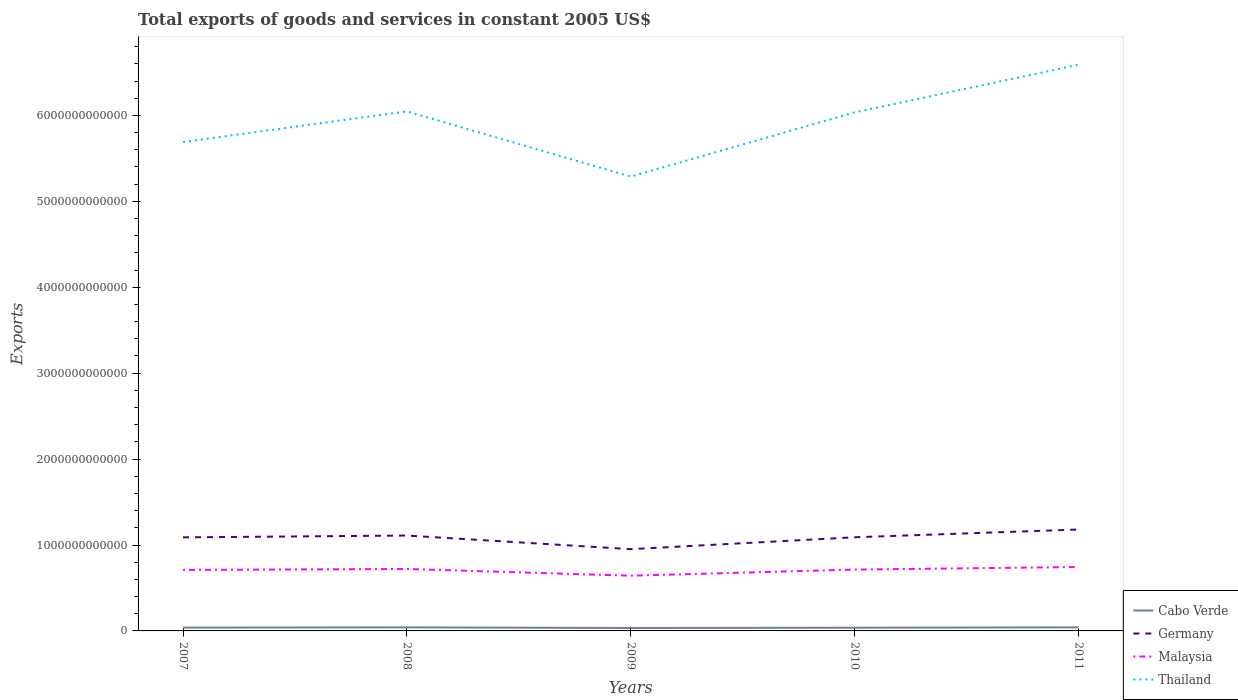Does the line corresponding to Cabo Verde intersect with the line corresponding to Malaysia?
Ensure brevity in your answer.  No. Across all years, what is the maximum total exports of goods and services in Cabo Verde?
Keep it short and to the point. 3.41e+1. In which year was the total exports of goods and services in Cabo Verde maximum?
Offer a terse response. 2009. What is the total total exports of goods and services in Cabo Verde in the graph?
Offer a very short reply. 7.21e+09. What is the difference between the highest and the second highest total exports of goods and services in Thailand?
Your answer should be compact. 1.30e+12. What is the difference between the highest and the lowest total exports of goods and services in Thailand?
Ensure brevity in your answer.  3. What is the difference between two consecutive major ticks on the Y-axis?
Provide a succinct answer. 1.00e+12. Are the values on the major ticks of Y-axis written in scientific E-notation?
Your response must be concise. No. Does the graph contain any zero values?
Give a very brief answer. No. Does the graph contain grids?
Offer a very short reply. No. How many legend labels are there?
Your response must be concise. 4. What is the title of the graph?
Ensure brevity in your answer.  Total exports of goods and services in constant 2005 US$. What is the label or title of the Y-axis?
Provide a short and direct response. Exports. What is the Exports in Cabo Verde in 2007?
Offer a very short reply. 3.85e+1. What is the Exports in Germany in 2007?
Your response must be concise. 1.09e+12. What is the Exports of Malaysia in 2007?
Your response must be concise. 7.10e+11. What is the Exports of Thailand in 2007?
Your response must be concise. 5.69e+12. What is the Exports of Cabo Verde in 2008?
Provide a succinct answer. 4.13e+1. What is the Exports in Germany in 2008?
Your answer should be very brief. 1.11e+12. What is the Exports in Malaysia in 2008?
Give a very brief answer. 7.21e+11. What is the Exports of Thailand in 2008?
Ensure brevity in your answer.  6.05e+12. What is the Exports in Cabo Verde in 2009?
Offer a terse response. 3.41e+1. What is the Exports in Germany in 2009?
Make the answer very short. 9.52e+11. What is the Exports of Malaysia in 2009?
Provide a succinct answer. 6.43e+11. What is the Exports in Thailand in 2009?
Offer a very short reply. 5.29e+12. What is the Exports in Cabo Verde in 2010?
Provide a succinct answer. 3.73e+1. What is the Exports of Germany in 2010?
Keep it short and to the point. 1.09e+12. What is the Exports of Malaysia in 2010?
Offer a terse response. 7.14e+11. What is the Exports of Thailand in 2010?
Provide a succinct answer. 6.04e+12. What is the Exports of Cabo Verde in 2011?
Offer a terse response. 4.15e+1. What is the Exports in Germany in 2011?
Offer a terse response. 1.18e+12. What is the Exports in Malaysia in 2011?
Your response must be concise. 7.44e+11. What is the Exports of Thailand in 2011?
Offer a very short reply. 6.59e+12. Across all years, what is the maximum Exports of Cabo Verde?
Provide a succinct answer. 4.15e+1. Across all years, what is the maximum Exports in Germany?
Give a very brief answer. 1.18e+12. Across all years, what is the maximum Exports of Malaysia?
Keep it short and to the point. 7.44e+11. Across all years, what is the maximum Exports of Thailand?
Your answer should be compact. 6.59e+12. Across all years, what is the minimum Exports in Cabo Verde?
Provide a succinct answer. 3.41e+1. Across all years, what is the minimum Exports of Germany?
Provide a succinct answer. 9.52e+11. Across all years, what is the minimum Exports in Malaysia?
Your answer should be compact. 6.43e+11. Across all years, what is the minimum Exports of Thailand?
Provide a short and direct response. 5.29e+12. What is the total Exports in Cabo Verde in the graph?
Give a very brief answer. 1.93e+11. What is the total Exports of Germany in the graph?
Your response must be concise. 5.42e+12. What is the total Exports of Malaysia in the graph?
Offer a terse response. 3.53e+12. What is the total Exports of Thailand in the graph?
Your answer should be very brief. 2.97e+13. What is the difference between the Exports of Cabo Verde in 2007 and that in 2008?
Provide a succinct answer. -2.83e+09. What is the difference between the Exports in Germany in 2007 and that in 2008?
Provide a short and direct response. -2.10e+1. What is the difference between the Exports in Malaysia in 2007 and that in 2008?
Provide a succinct answer. -1.12e+1. What is the difference between the Exports of Thailand in 2007 and that in 2008?
Your response must be concise. -3.56e+11. What is the difference between the Exports of Cabo Verde in 2007 and that in 2009?
Your response must be concise. 4.38e+09. What is the difference between the Exports in Germany in 2007 and that in 2009?
Ensure brevity in your answer.  1.37e+11. What is the difference between the Exports of Malaysia in 2007 and that in 2009?
Your response must be concise. 6.73e+1. What is the difference between the Exports in Thailand in 2007 and that in 2009?
Offer a very short reply. 4.02e+11. What is the difference between the Exports of Cabo Verde in 2007 and that in 2010?
Provide a succinct answer. 1.20e+09. What is the difference between the Exports in Germany in 2007 and that in 2010?
Keep it short and to the point. -9.81e+08. What is the difference between the Exports in Malaysia in 2007 and that in 2010?
Provide a succinct answer. -4.16e+09. What is the difference between the Exports in Thailand in 2007 and that in 2010?
Provide a short and direct response. -3.45e+11. What is the difference between the Exports in Cabo Verde in 2007 and that in 2011?
Provide a succinct answer. -3.00e+09. What is the difference between the Exports of Germany in 2007 and that in 2011?
Your response must be concise. -9.12e+1. What is the difference between the Exports of Malaysia in 2007 and that in 2011?
Keep it short and to the point. -3.40e+1. What is the difference between the Exports of Thailand in 2007 and that in 2011?
Your answer should be compact. -8.99e+11. What is the difference between the Exports in Cabo Verde in 2008 and that in 2009?
Ensure brevity in your answer.  7.21e+09. What is the difference between the Exports in Germany in 2008 and that in 2009?
Your answer should be compact. 1.58e+11. What is the difference between the Exports in Malaysia in 2008 and that in 2009?
Ensure brevity in your answer.  7.84e+1. What is the difference between the Exports in Thailand in 2008 and that in 2009?
Your response must be concise. 7.59e+11. What is the difference between the Exports in Cabo Verde in 2008 and that in 2010?
Your answer should be very brief. 4.03e+09. What is the difference between the Exports of Germany in 2008 and that in 2010?
Give a very brief answer. 2.01e+1. What is the difference between the Exports in Malaysia in 2008 and that in 2010?
Offer a very short reply. 7.01e+09. What is the difference between the Exports in Thailand in 2008 and that in 2010?
Provide a short and direct response. 1.11e+1. What is the difference between the Exports in Cabo Verde in 2008 and that in 2011?
Give a very brief answer. -1.64e+08. What is the difference between the Exports of Germany in 2008 and that in 2011?
Ensure brevity in your answer.  -7.02e+1. What is the difference between the Exports of Malaysia in 2008 and that in 2011?
Make the answer very short. -2.28e+1. What is the difference between the Exports of Thailand in 2008 and that in 2011?
Your answer should be compact. -5.43e+11. What is the difference between the Exports in Cabo Verde in 2009 and that in 2010?
Your answer should be very brief. -3.18e+09. What is the difference between the Exports of Germany in 2009 and that in 2010?
Give a very brief answer. -1.38e+11. What is the difference between the Exports of Malaysia in 2009 and that in 2010?
Ensure brevity in your answer.  -7.14e+1. What is the difference between the Exports of Thailand in 2009 and that in 2010?
Ensure brevity in your answer.  -7.47e+11. What is the difference between the Exports in Cabo Verde in 2009 and that in 2011?
Offer a terse response. -7.37e+09. What is the difference between the Exports of Germany in 2009 and that in 2011?
Your response must be concise. -2.29e+11. What is the difference between the Exports in Malaysia in 2009 and that in 2011?
Provide a succinct answer. -1.01e+11. What is the difference between the Exports in Thailand in 2009 and that in 2011?
Make the answer very short. -1.30e+12. What is the difference between the Exports in Cabo Verde in 2010 and that in 2011?
Your answer should be very brief. -4.19e+09. What is the difference between the Exports in Germany in 2010 and that in 2011?
Give a very brief answer. -9.03e+1. What is the difference between the Exports of Malaysia in 2010 and that in 2011?
Make the answer very short. -2.98e+1. What is the difference between the Exports of Thailand in 2010 and that in 2011?
Offer a very short reply. -5.54e+11. What is the difference between the Exports of Cabo Verde in 2007 and the Exports of Germany in 2008?
Your answer should be compact. -1.07e+12. What is the difference between the Exports of Cabo Verde in 2007 and the Exports of Malaysia in 2008?
Provide a short and direct response. -6.83e+11. What is the difference between the Exports in Cabo Verde in 2007 and the Exports in Thailand in 2008?
Provide a succinct answer. -6.01e+12. What is the difference between the Exports in Germany in 2007 and the Exports in Malaysia in 2008?
Your answer should be very brief. 3.68e+11. What is the difference between the Exports of Germany in 2007 and the Exports of Thailand in 2008?
Provide a short and direct response. -4.96e+12. What is the difference between the Exports of Malaysia in 2007 and the Exports of Thailand in 2008?
Offer a terse response. -5.34e+12. What is the difference between the Exports of Cabo Verde in 2007 and the Exports of Germany in 2009?
Your answer should be very brief. -9.13e+11. What is the difference between the Exports of Cabo Verde in 2007 and the Exports of Malaysia in 2009?
Your answer should be compact. -6.04e+11. What is the difference between the Exports in Cabo Verde in 2007 and the Exports in Thailand in 2009?
Ensure brevity in your answer.  -5.25e+12. What is the difference between the Exports of Germany in 2007 and the Exports of Malaysia in 2009?
Your answer should be very brief. 4.46e+11. What is the difference between the Exports of Germany in 2007 and the Exports of Thailand in 2009?
Keep it short and to the point. -4.20e+12. What is the difference between the Exports in Malaysia in 2007 and the Exports in Thailand in 2009?
Make the answer very short. -4.58e+12. What is the difference between the Exports of Cabo Verde in 2007 and the Exports of Germany in 2010?
Give a very brief answer. -1.05e+12. What is the difference between the Exports of Cabo Verde in 2007 and the Exports of Malaysia in 2010?
Keep it short and to the point. -6.76e+11. What is the difference between the Exports in Cabo Verde in 2007 and the Exports in Thailand in 2010?
Keep it short and to the point. -6.00e+12. What is the difference between the Exports of Germany in 2007 and the Exports of Malaysia in 2010?
Your answer should be compact. 3.75e+11. What is the difference between the Exports in Germany in 2007 and the Exports in Thailand in 2010?
Your answer should be very brief. -4.95e+12. What is the difference between the Exports in Malaysia in 2007 and the Exports in Thailand in 2010?
Your answer should be compact. -5.33e+12. What is the difference between the Exports in Cabo Verde in 2007 and the Exports in Germany in 2011?
Your response must be concise. -1.14e+12. What is the difference between the Exports in Cabo Verde in 2007 and the Exports in Malaysia in 2011?
Make the answer very short. -7.05e+11. What is the difference between the Exports in Cabo Verde in 2007 and the Exports in Thailand in 2011?
Keep it short and to the point. -6.55e+12. What is the difference between the Exports in Germany in 2007 and the Exports in Malaysia in 2011?
Your answer should be compact. 3.45e+11. What is the difference between the Exports of Germany in 2007 and the Exports of Thailand in 2011?
Give a very brief answer. -5.50e+12. What is the difference between the Exports in Malaysia in 2007 and the Exports in Thailand in 2011?
Provide a short and direct response. -5.88e+12. What is the difference between the Exports in Cabo Verde in 2008 and the Exports in Germany in 2009?
Keep it short and to the point. -9.10e+11. What is the difference between the Exports of Cabo Verde in 2008 and the Exports of Malaysia in 2009?
Your response must be concise. -6.01e+11. What is the difference between the Exports of Cabo Verde in 2008 and the Exports of Thailand in 2009?
Give a very brief answer. -5.25e+12. What is the difference between the Exports of Germany in 2008 and the Exports of Malaysia in 2009?
Your answer should be compact. 4.68e+11. What is the difference between the Exports in Germany in 2008 and the Exports in Thailand in 2009?
Your answer should be very brief. -4.18e+12. What is the difference between the Exports in Malaysia in 2008 and the Exports in Thailand in 2009?
Your answer should be very brief. -4.57e+12. What is the difference between the Exports of Cabo Verde in 2008 and the Exports of Germany in 2010?
Your response must be concise. -1.05e+12. What is the difference between the Exports in Cabo Verde in 2008 and the Exports in Malaysia in 2010?
Make the answer very short. -6.73e+11. What is the difference between the Exports in Cabo Verde in 2008 and the Exports in Thailand in 2010?
Provide a succinct answer. -5.99e+12. What is the difference between the Exports in Germany in 2008 and the Exports in Malaysia in 2010?
Offer a very short reply. 3.96e+11. What is the difference between the Exports of Germany in 2008 and the Exports of Thailand in 2010?
Give a very brief answer. -4.93e+12. What is the difference between the Exports of Malaysia in 2008 and the Exports of Thailand in 2010?
Offer a terse response. -5.31e+12. What is the difference between the Exports in Cabo Verde in 2008 and the Exports in Germany in 2011?
Ensure brevity in your answer.  -1.14e+12. What is the difference between the Exports of Cabo Verde in 2008 and the Exports of Malaysia in 2011?
Provide a succinct answer. -7.03e+11. What is the difference between the Exports in Cabo Verde in 2008 and the Exports in Thailand in 2011?
Make the answer very short. -6.55e+12. What is the difference between the Exports of Germany in 2008 and the Exports of Malaysia in 2011?
Provide a succinct answer. 3.66e+11. What is the difference between the Exports in Germany in 2008 and the Exports in Thailand in 2011?
Offer a very short reply. -5.48e+12. What is the difference between the Exports in Malaysia in 2008 and the Exports in Thailand in 2011?
Offer a very short reply. -5.87e+12. What is the difference between the Exports in Cabo Verde in 2009 and the Exports in Germany in 2010?
Offer a terse response. -1.06e+12. What is the difference between the Exports in Cabo Verde in 2009 and the Exports in Malaysia in 2010?
Provide a succinct answer. -6.80e+11. What is the difference between the Exports of Cabo Verde in 2009 and the Exports of Thailand in 2010?
Provide a short and direct response. -6.00e+12. What is the difference between the Exports in Germany in 2009 and the Exports in Malaysia in 2010?
Ensure brevity in your answer.  2.38e+11. What is the difference between the Exports in Germany in 2009 and the Exports in Thailand in 2010?
Provide a short and direct response. -5.08e+12. What is the difference between the Exports in Malaysia in 2009 and the Exports in Thailand in 2010?
Provide a short and direct response. -5.39e+12. What is the difference between the Exports in Cabo Verde in 2009 and the Exports in Germany in 2011?
Your answer should be compact. -1.15e+12. What is the difference between the Exports in Cabo Verde in 2009 and the Exports in Malaysia in 2011?
Keep it short and to the point. -7.10e+11. What is the difference between the Exports of Cabo Verde in 2009 and the Exports of Thailand in 2011?
Give a very brief answer. -6.56e+12. What is the difference between the Exports of Germany in 2009 and the Exports of Malaysia in 2011?
Your response must be concise. 2.08e+11. What is the difference between the Exports in Germany in 2009 and the Exports in Thailand in 2011?
Provide a short and direct response. -5.64e+12. What is the difference between the Exports of Malaysia in 2009 and the Exports of Thailand in 2011?
Give a very brief answer. -5.95e+12. What is the difference between the Exports in Cabo Verde in 2010 and the Exports in Germany in 2011?
Offer a terse response. -1.14e+12. What is the difference between the Exports of Cabo Verde in 2010 and the Exports of Malaysia in 2011?
Provide a short and direct response. -7.07e+11. What is the difference between the Exports in Cabo Verde in 2010 and the Exports in Thailand in 2011?
Provide a short and direct response. -6.55e+12. What is the difference between the Exports in Germany in 2010 and the Exports in Malaysia in 2011?
Make the answer very short. 3.46e+11. What is the difference between the Exports in Germany in 2010 and the Exports in Thailand in 2011?
Your answer should be very brief. -5.50e+12. What is the difference between the Exports of Malaysia in 2010 and the Exports of Thailand in 2011?
Provide a succinct answer. -5.88e+12. What is the average Exports of Cabo Verde per year?
Ensure brevity in your answer.  3.85e+1. What is the average Exports in Germany per year?
Your answer should be compact. 1.08e+12. What is the average Exports of Malaysia per year?
Give a very brief answer. 7.06e+11. What is the average Exports of Thailand per year?
Provide a short and direct response. 5.93e+12. In the year 2007, what is the difference between the Exports in Cabo Verde and Exports in Germany?
Ensure brevity in your answer.  -1.05e+12. In the year 2007, what is the difference between the Exports in Cabo Verde and Exports in Malaysia?
Ensure brevity in your answer.  -6.71e+11. In the year 2007, what is the difference between the Exports in Cabo Verde and Exports in Thailand?
Your response must be concise. -5.65e+12. In the year 2007, what is the difference between the Exports in Germany and Exports in Malaysia?
Provide a succinct answer. 3.79e+11. In the year 2007, what is the difference between the Exports of Germany and Exports of Thailand?
Give a very brief answer. -4.60e+12. In the year 2007, what is the difference between the Exports in Malaysia and Exports in Thailand?
Your response must be concise. -4.98e+12. In the year 2008, what is the difference between the Exports in Cabo Verde and Exports in Germany?
Your response must be concise. -1.07e+12. In the year 2008, what is the difference between the Exports of Cabo Verde and Exports of Malaysia?
Your answer should be very brief. -6.80e+11. In the year 2008, what is the difference between the Exports in Cabo Verde and Exports in Thailand?
Your answer should be very brief. -6.01e+12. In the year 2008, what is the difference between the Exports of Germany and Exports of Malaysia?
Offer a very short reply. 3.89e+11. In the year 2008, what is the difference between the Exports of Germany and Exports of Thailand?
Your answer should be very brief. -4.94e+12. In the year 2008, what is the difference between the Exports in Malaysia and Exports in Thailand?
Keep it short and to the point. -5.33e+12. In the year 2009, what is the difference between the Exports in Cabo Verde and Exports in Germany?
Offer a very short reply. -9.18e+11. In the year 2009, what is the difference between the Exports of Cabo Verde and Exports of Malaysia?
Your answer should be compact. -6.09e+11. In the year 2009, what is the difference between the Exports of Cabo Verde and Exports of Thailand?
Offer a very short reply. -5.25e+12. In the year 2009, what is the difference between the Exports in Germany and Exports in Malaysia?
Ensure brevity in your answer.  3.09e+11. In the year 2009, what is the difference between the Exports of Germany and Exports of Thailand?
Ensure brevity in your answer.  -4.34e+12. In the year 2009, what is the difference between the Exports in Malaysia and Exports in Thailand?
Provide a succinct answer. -4.65e+12. In the year 2010, what is the difference between the Exports in Cabo Verde and Exports in Germany?
Your answer should be very brief. -1.05e+12. In the year 2010, what is the difference between the Exports in Cabo Verde and Exports in Malaysia?
Your answer should be compact. -6.77e+11. In the year 2010, what is the difference between the Exports in Cabo Verde and Exports in Thailand?
Provide a succinct answer. -6.00e+12. In the year 2010, what is the difference between the Exports in Germany and Exports in Malaysia?
Your response must be concise. 3.76e+11. In the year 2010, what is the difference between the Exports in Germany and Exports in Thailand?
Your answer should be very brief. -4.95e+12. In the year 2010, what is the difference between the Exports of Malaysia and Exports of Thailand?
Give a very brief answer. -5.32e+12. In the year 2011, what is the difference between the Exports in Cabo Verde and Exports in Germany?
Ensure brevity in your answer.  -1.14e+12. In the year 2011, what is the difference between the Exports of Cabo Verde and Exports of Malaysia?
Your response must be concise. -7.02e+11. In the year 2011, what is the difference between the Exports in Cabo Verde and Exports in Thailand?
Provide a short and direct response. -6.55e+12. In the year 2011, what is the difference between the Exports of Germany and Exports of Malaysia?
Keep it short and to the point. 4.36e+11. In the year 2011, what is the difference between the Exports of Germany and Exports of Thailand?
Your answer should be compact. -5.41e+12. In the year 2011, what is the difference between the Exports in Malaysia and Exports in Thailand?
Ensure brevity in your answer.  -5.85e+12. What is the ratio of the Exports in Cabo Verde in 2007 to that in 2008?
Make the answer very short. 0.93. What is the ratio of the Exports in Malaysia in 2007 to that in 2008?
Provide a short and direct response. 0.98. What is the ratio of the Exports in Thailand in 2007 to that in 2008?
Offer a very short reply. 0.94. What is the ratio of the Exports in Cabo Verde in 2007 to that in 2009?
Give a very brief answer. 1.13. What is the ratio of the Exports of Germany in 2007 to that in 2009?
Provide a short and direct response. 1.14. What is the ratio of the Exports of Malaysia in 2007 to that in 2009?
Keep it short and to the point. 1.1. What is the ratio of the Exports in Thailand in 2007 to that in 2009?
Your answer should be very brief. 1.08. What is the ratio of the Exports in Cabo Verde in 2007 to that in 2010?
Make the answer very short. 1.03. What is the ratio of the Exports of Malaysia in 2007 to that in 2010?
Give a very brief answer. 0.99. What is the ratio of the Exports in Thailand in 2007 to that in 2010?
Your response must be concise. 0.94. What is the ratio of the Exports in Cabo Verde in 2007 to that in 2011?
Make the answer very short. 0.93. What is the ratio of the Exports in Germany in 2007 to that in 2011?
Offer a very short reply. 0.92. What is the ratio of the Exports in Malaysia in 2007 to that in 2011?
Give a very brief answer. 0.95. What is the ratio of the Exports in Thailand in 2007 to that in 2011?
Provide a succinct answer. 0.86. What is the ratio of the Exports in Cabo Verde in 2008 to that in 2009?
Provide a succinct answer. 1.21. What is the ratio of the Exports of Germany in 2008 to that in 2009?
Offer a terse response. 1.17. What is the ratio of the Exports in Malaysia in 2008 to that in 2009?
Provide a short and direct response. 1.12. What is the ratio of the Exports of Thailand in 2008 to that in 2009?
Offer a very short reply. 1.14. What is the ratio of the Exports in Cabo Verde in 2008 to that in 2010?
Your answer should be compact. 1.11. What is the ratio of the Exports in Germany in 2008 to that in 2010?
Make the answer very short. 1.02. What is the ratio of the Exports in Malaysia in 2008 to that in 2010?
Ensure brevity in your answer.  1.01. What is the ratio of the Exports of Thailand in 2008 to that in 2010?
Your answer should be compact. 1. What is the ratio of the Exports in Cabo Verde in 2008 to that in 2011?
Make the answer very short. 1. What is the ratio of the Exports of Germany in 2008 to that in 2011?
Keep it short and to the point. 0.94. What is the ratio of the Exports of Malaysia in 2008 to that in 2011?
Your response must be concise. 0.97. What is the ratio of the Exports in Thailand in 2008 to that in 2011?
Your answer should be very brief. 0.92. What is the ratio of the Exports of Cabo Verde in 2009 to that in 2010?
Keep it short and to the point. 0.91. What is the ratio of the Exports in Germany in 2009 to that in 2010?
Your response must be concise. 0.87. What is the ratio of the Exports in Thailand in 2009 to that in 2010?
Provide a short and direct response. 0.88. What is the ratio of the Exports of Cabo Verde in 2009 to that in 2011?
Your response must be concise. 0.82. What is the ratio of the Exports of Germany in 2009 to that in 2011?
Make the answer very short. 0.81. What is the ratio of the Exports of Malaysia in 2009 to that in 2011?
Ensure brevity in your answer.  0.86. What is the ratio of the Exports of Thailand in 2009 to that in 2011?
Provide a succinct answer. 0.8. What is the ratio of the Exports of Cabo Verde in 2010 to that in 2011?
Provide a short and direct response. 0.9. What is the ratio of the Exports of Germany in 2010 to that in 2011?
Provide a succinct answer. 0.92. What is the ratio of the Exports in Malaysia in 2010 to that in 2011?
Ensure brevity in your answer.  0.96. What is the ratio of the Exports in Thailand in 2010 to that in 2011?
Offer a very short reply. 0.92. What is the difference between the highest and the second highest Exports of Cabo Verde?
Your answer should be compact. 1.64e+08. What is the difference between the highest and the second highest Exports in Germany?
Provide a short and direct response. 7.02e+1. What is the difference between the highest and the second highest Exports in Malaysia?
Offer a very short reply. 2.28e+1. What is the difference between the highest and the second highest Exports in Thailand?
Ensure brevity in your answer.  5.43e+11. What is the difference between the highest and the lowest Exports of Cabo Verde?
Provide a short and direct response. 7.37e+09. What is the difference between the highest and the lowest Exports in Germany?
Provide a short and direct response. 2.29e+11. What is the difference between the highest and the lowest Exports of Malaysia?
Ensure brevity in your answer.  1.01e+11. What is the difference between the highest and the lowest Exports in Thailand?
Your answer should be very brief. 1.30e+12. 